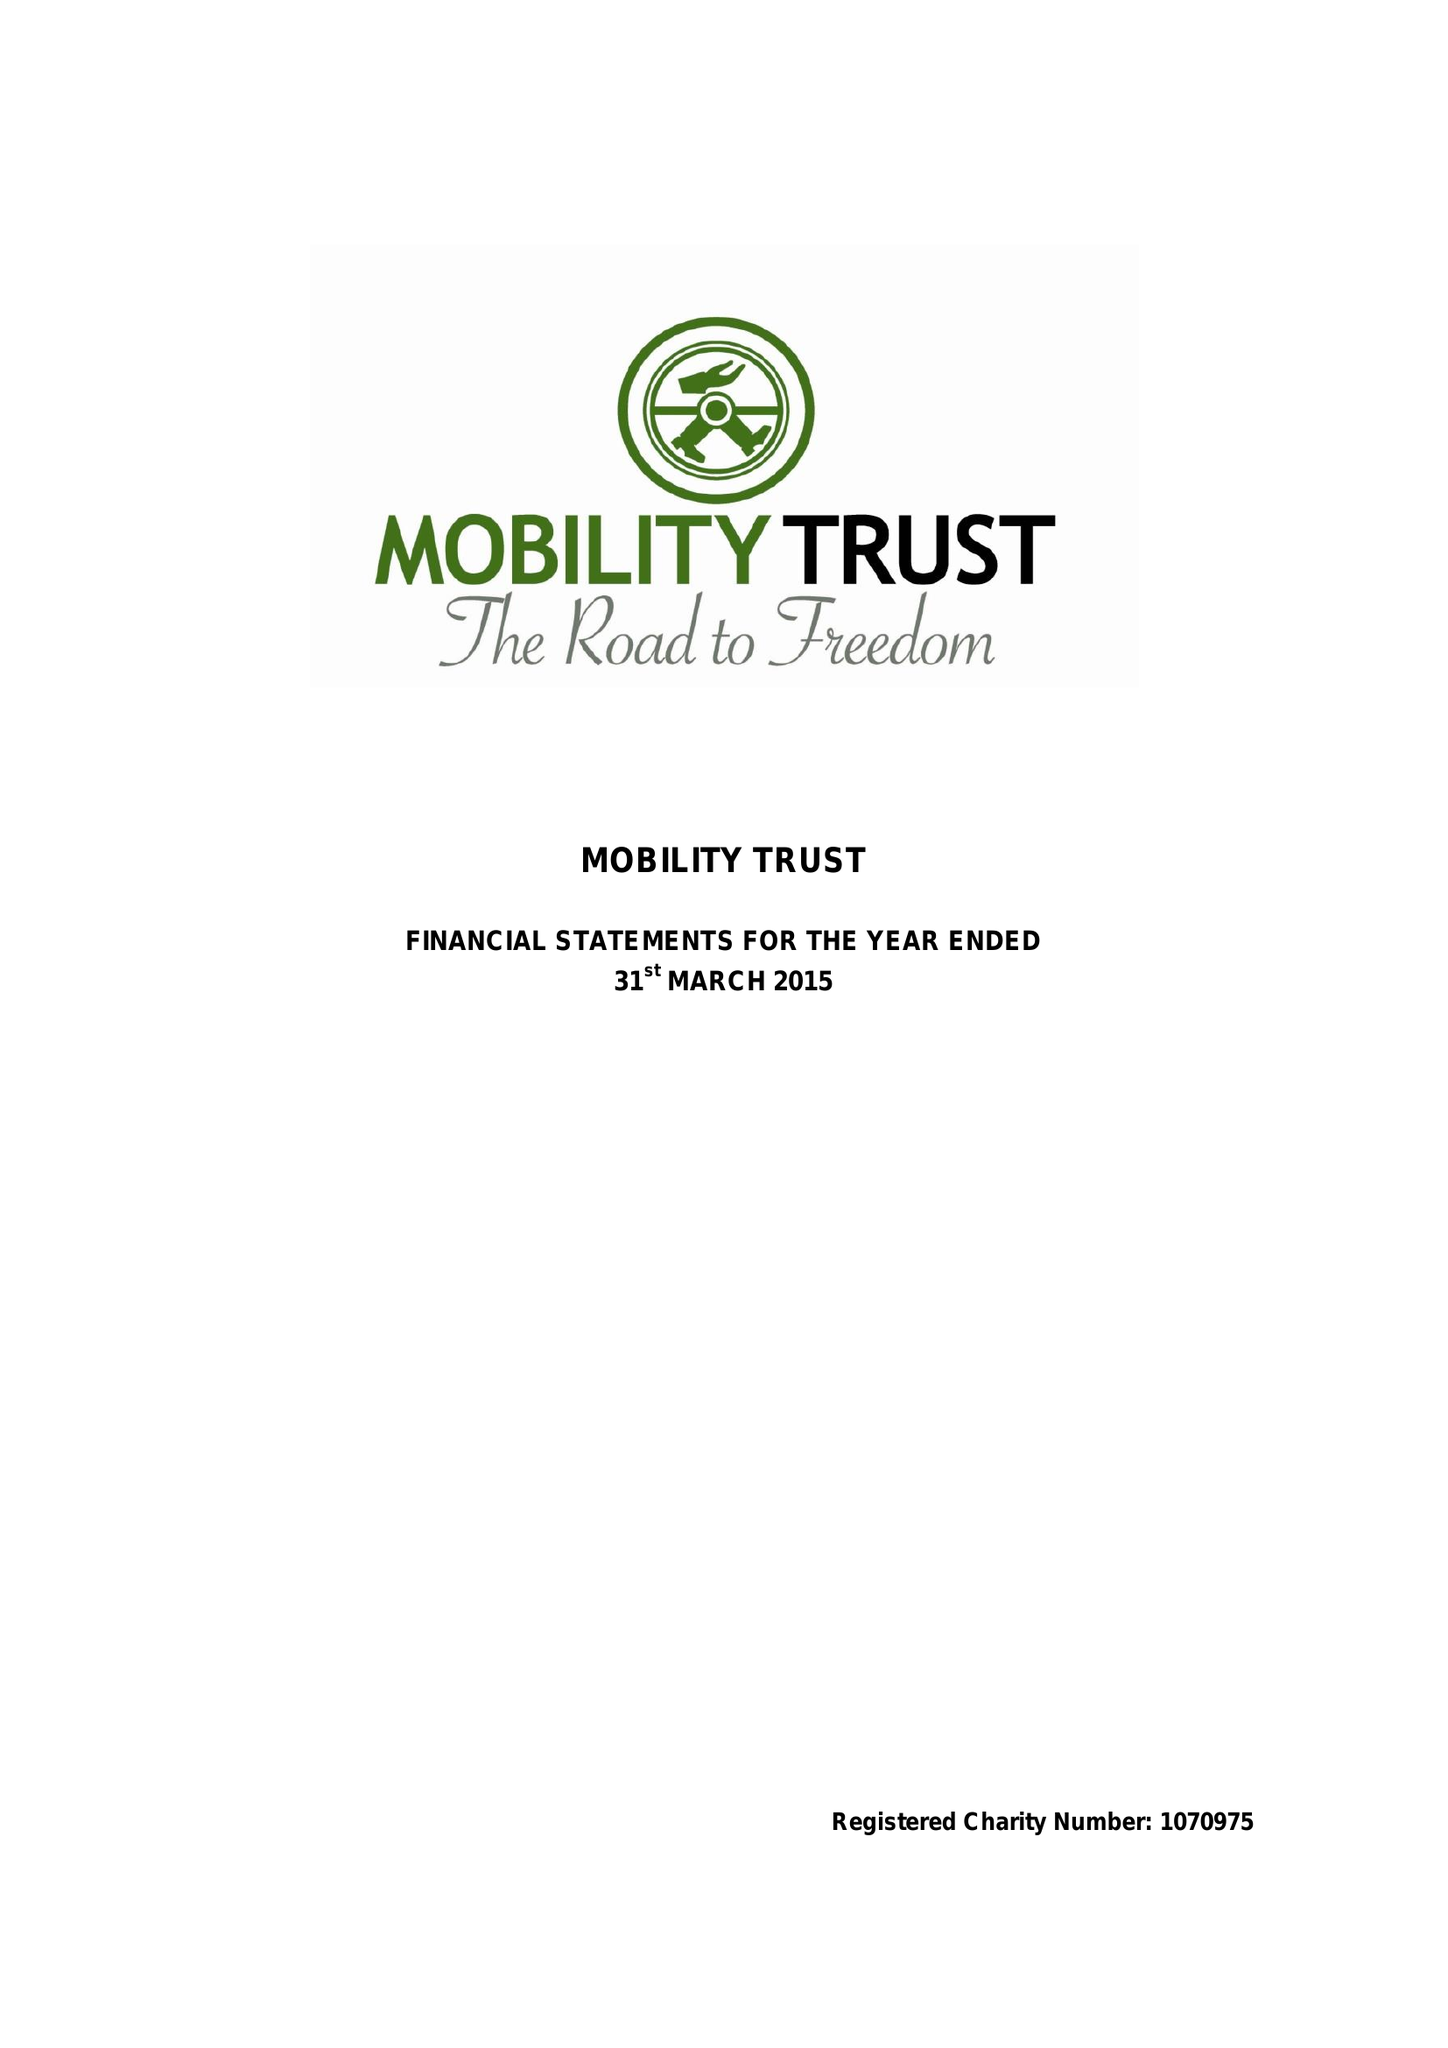What is the value for the charity_number?
Answer the question using a single word or phrase. 1070975 